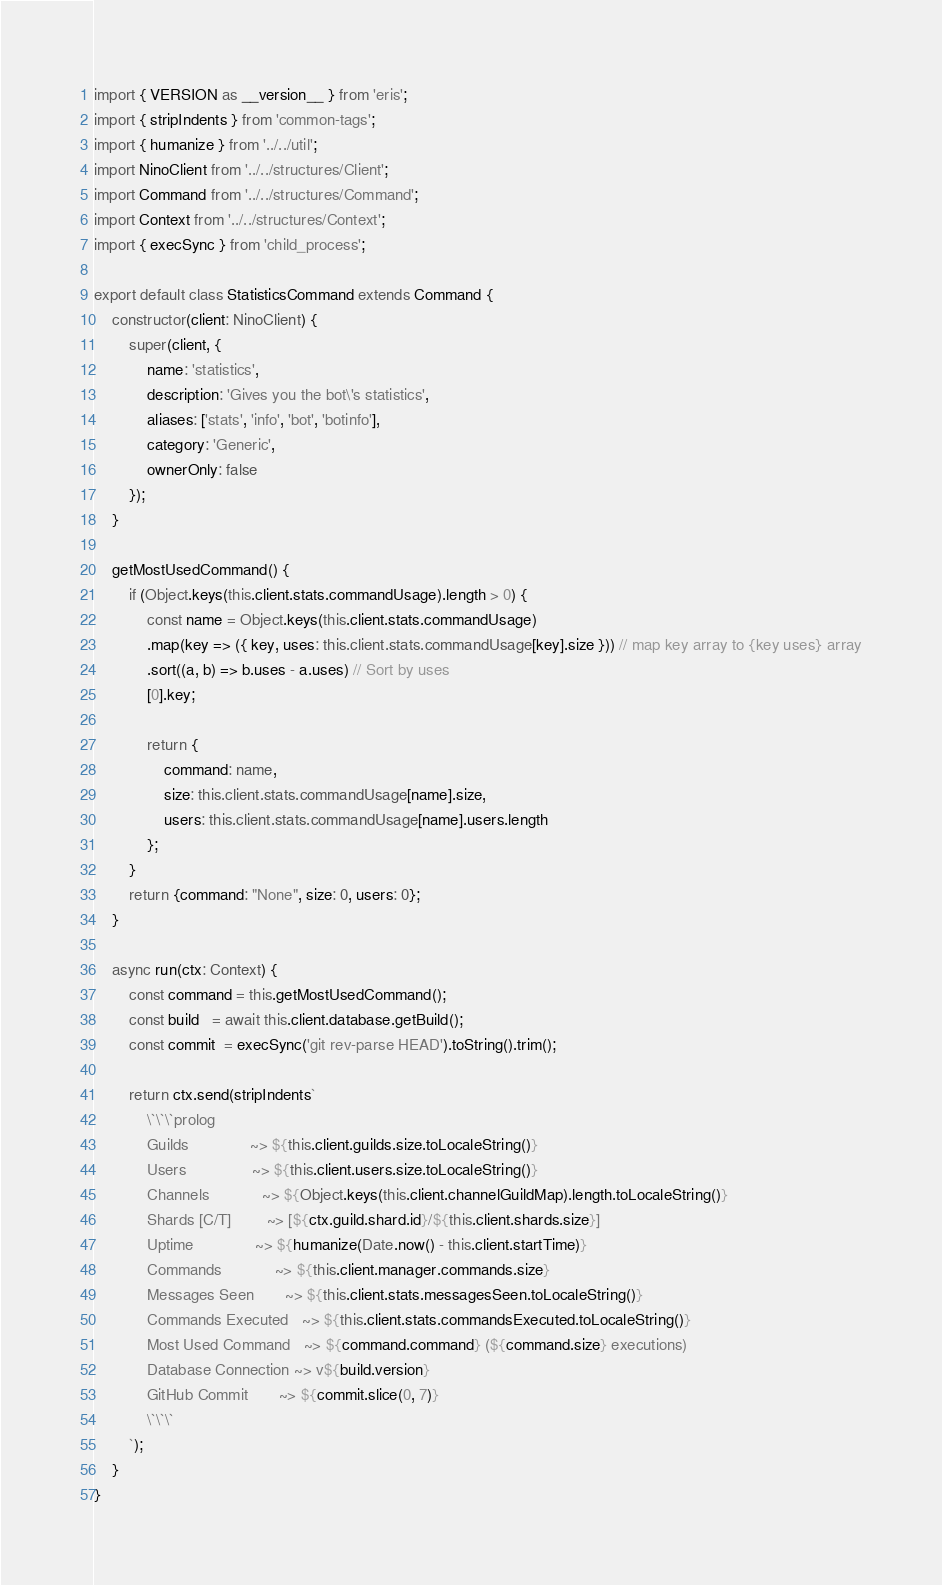<code> <loc_0><loc_0><loc_500><loc_500><_TypeScript_>import { VERSION as __version__ } from 'eris';
import { stripIndents } from 'common-tags';
import { humanize } from '../../util';
import NinoClient from '../../structures/Client';
import Command from '../../structures/Command';
import Context from '../../structures/Context';
import { execSync } from 'child_process';

export default class StatisticsCommand extends Command {
    constructor(client: NinoClient) {
        super(client, {
            name: 'statistics',
            description: 'Gives you the bot\'s statistics',
            aliases: ['stats', 'info', 'bot', 'botinfo'],
            category: 'Generic',
            ownerOnly: false
        });
    }

    getMostUsedCommand() {
        if (Object.keys(this.client.stats.commandUsage).length > 0) {
            const name = Object.keys(this.client.stats.commandUsage)
            .map(key => ({ key, uses: this.client.stats.commandUsage[key].size })) // map key array to {key uses} array
            .sort((a, b) => b.uses - a.uses) // Sort by uses
            [0].key;

            return {
                command: name,
                size: this.client.stats.commandUsage[name].size,
                users: this.client.stats.commandUsage[name].users.length
            };  
        }
        return {command: "None", size: 0, users: 0};
    }

    async run(ctx: Context) {
        const command = this.getMostUsedCommand();
        const build   = await this.client.database.getBuild();
        const commit  = execSync('git rev-parse HEAD').toString().trim();
        
        return ctx.send(stripIndents`
            \`\`\`prolog
            Guilds              ~> ${this.client.guilds.size.toLocaleString()}
            Users               ~> ${this.client.users.size.toLocaleString()}
            Channels            ~> ${Object.keys(this.client.channelGuildMap).length.toLocaleString()}
            Shards [C/T]        ~> [${ctx.guild.shard.id}/${this.client.shards.size}]
            Uptime              ~> ${humanize(Date.now() - this.client.startTime)}
            Commands            ~> ${this.client.manager.commands.size}
            Messages Seen       ~> ${this.client.stats.messagesSeen.toLocaleString()}
            Commands Executed   ~> ${this.client.stats.commandsExecuted.toLocaleString()}
            Most Used Command   ~> ${command.command} (${command.size} executions)
            Database Connection ~> v${build.version}
            GitHub Commit       ~> ${commit.slice(0, 7)}
            \`\`\`
        `);
    }
}</code> 